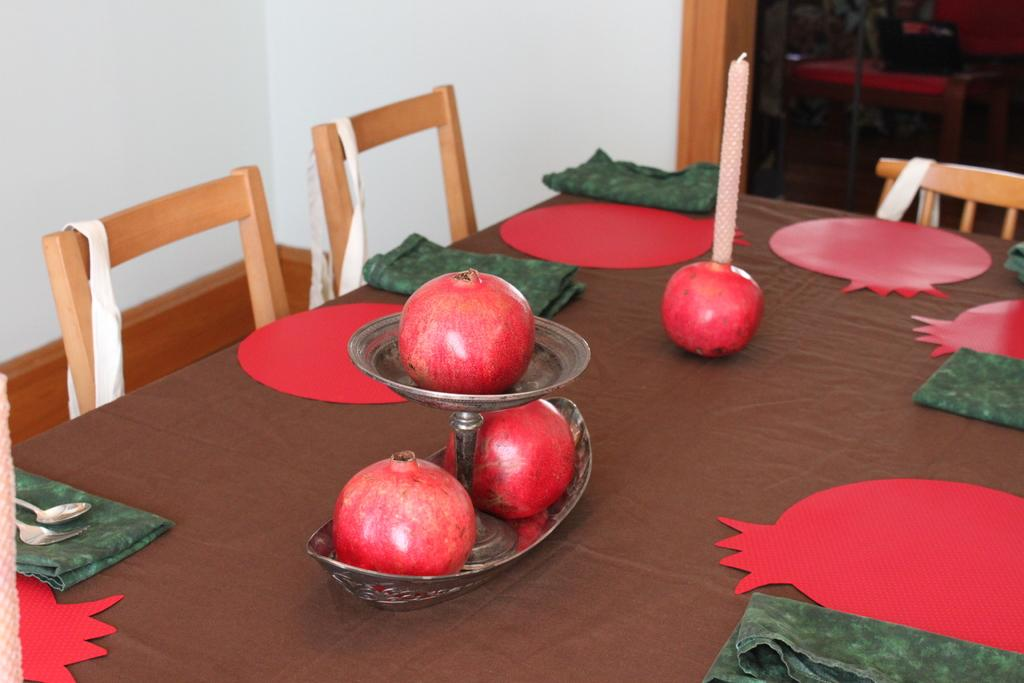What type of fruit is in the bowl in the image? There is a pomegranate in a bowl in the image. What utensils are visible in the image? There is a fork and a spoon in the image. What type of fabric is present in the image? There is a cloth in the image. What type of light source is in the image? There is a candle in the image. What type of furniture is in the image? There is a table and a chair in the image. What type of plant is in the image? There is a plant in the image. How does the paper cry in the image? There is no paper present in the image, and therefore no such activity can be observed. 